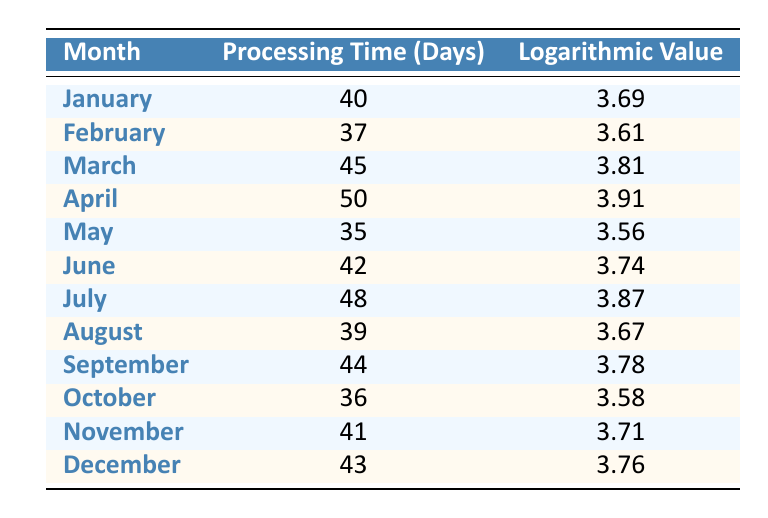What is the processing time for April? The table shows that April has a processing time of 50 days listed directly under the 'Processing Time (Days)' column for that month.
Answer: 50 Which month had the shortest processing time? By reviewing the 'Processing Time (Days)' column, May shows the lowest value of 35 days, making it the month with the shortest processing time.
Answer: May How many days did the processing time increase from January to March? From January's processing time of 40 days to March's processing time of 45 days, we can calculate the increase by subtracting: 45 - 40 = 5.
Answer: 5 Is it true that the logarithmic value for February is lower than that for January? Checking the 'Logarithmic Value' column, February's value is 3.61319, which is indeed lower than January's value of 3.68888. Therefore, this statement is true.
Answer: Yes What is the average processing time for the first half of the year (January to June)? We sum the processing times for these months: 40 (January) + 37 (February) + 45 (March) + 50 (April) + 35 (May) + 42 (June) = 249 days. Since there are 6 months, we divide by 6 to find the average: 249 / 6 = 41.5.
Answer: 41.5 Which month has the closest logarithmic value to 3.70? By inspecting the 'Logarithmic Value' column, July has a value of 3.87120, which is the closest to 3.70 when compared to other months.
Answer: July What is the difference in processing times between the month with the maximum and minimum processing times? The month with the maximum processing time is April with 50 days, and the minimum is May with 35 days. The difference is calculated as 50 - 35 = 15 days.
Answer: 15 Does the logarithmic value for October exceed that of December? Comparing the values, October's logarithmic value is 3.58352, while December's is 3.76120. Since 3.58352 is less than 3.76120, this statement is false.
Answer: No What was the average logarithmic value for the second half of the year (July to December)? The logarithmic values for these months are: July (3.87120), August (3.66725), September (3.78419), October (3.58352), November (3.71395), and December (3.76120). Adding these gives 3.87120 + 3.66725 + 3.78419 + 3.58352 + 3.71395 + 3.76120 = 22.38041. There are 6 months, so the average is 22.38041 / 6 = 3.73007.
Answer: 3.73007 